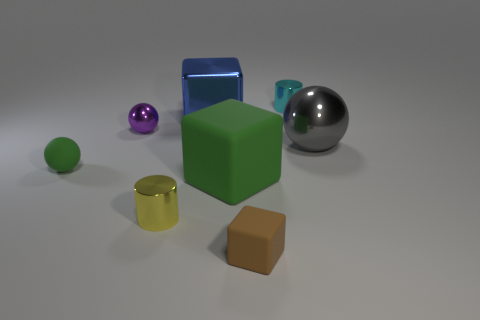What are the different colors of the objects in the scene? The objects in the scene display a variety of colors: green for the small sphere in the front, transparent blue for the solid cube, purple and silver for the two spheres, yellow for the cylinder, and brown for the cube at the front right. 